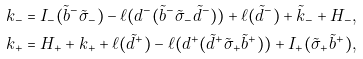Convert formula to latex. <formula><loc_0><loc_0><loc_500><loc_500>k _ { - } & = I _ { - } ( \tilde { b } ^ { - } \tilde { \sigma } _ { - } ) - \ell ( d ^ { - } ( \tilde { b } ^ { - } \tilde { \sigma } _ { - } \tilde { d } ^ { - } ) ) + \ell ( \tilde { d } ^ { - } ) + \tilde { k } _ { - } + H _ { - } , \\ k _ { + } & = H _ { + } + k _ { + } + \ell ( \tilde { d } ^ { + } ) - \ell ( d ^ { + } ( \tilde { d } ^ { + } \tilde { \sigma } _ { + } \tilde { b } ^ { + } ) ) + I _ { + } ( \tilde { \sigma } _ { + } \tilde { b } ^ { + } ) ,</formula> 